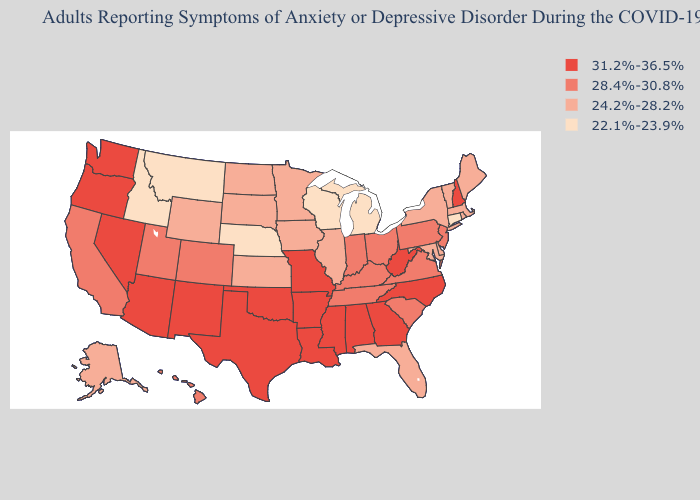What is the lowest value in states that border Louisiana?
Answer briefly. 31.2%-36.5%. What is the highest value in the South ?
Give a very brief answer. 31.2%-36.5%. Among the states that border Georgia , which have the lowest value?
Answer briefly. Florida. Name the states that have a value in the range 24.2%-28.2%?
Short answer required. Alaska, Delaware, Florida, Illinois, Iowa, Kansas, Maine, Maryland, Massachusetts, Minnesota, New York, North Dakota, Rhode Island, South Dakota, Vermont, Wyoming. Is the legend a continuous bar?
Keep it brief. No. What is the highest value in states that border Minnesota?
Keep it brief. 24.2%-28.2%. Does Iowa have a lower value than Georgia?
Answer briefly. Yes. What is the highest value in the USA?
Write a very short answer. 31.2%-36.5%. What is the lowest value in states that border Wyoming?
Concise answer only. 22.1%-23.9%. Among the states that border Vermont , which have the lowest value?
Short answer required. Massachusetts, New York. What is the highest value in the USA?
Concise answer only. 31.2%-36.5%. Which states have the lowest value in the Northeast?
Quick response, please. Connecticut. Name the states that have a value in the range 31.2%-36.5%?
Give a very brief answer. Alabama, Arizona, Arkansas, Georgia, Louisiana, Mississippi, Missouri, Nevada, New Hampshire, New Mexico, North Carolina, Oklahoma, Oregon, Texas, Washington, West Virginia. Name the states that have a value in the range 22.1%-23.9%?
Keep it brief. Connecticut, Idaho, Michigan, Montana, Nebraska, Wisconsin. 